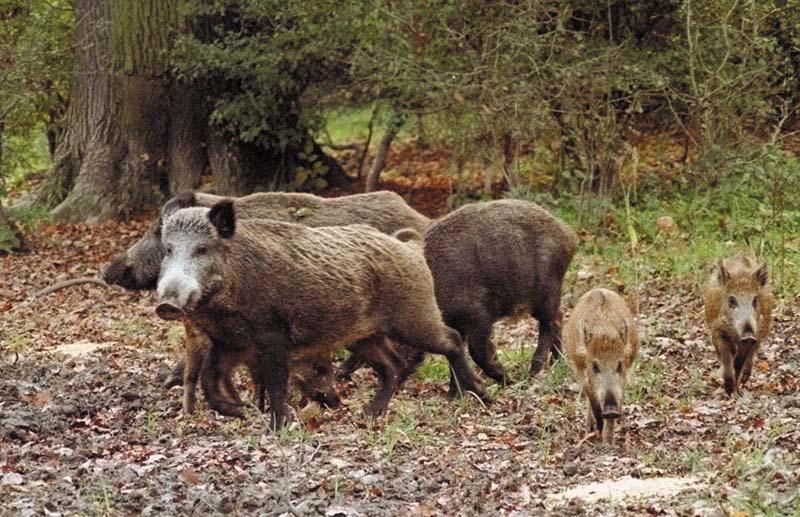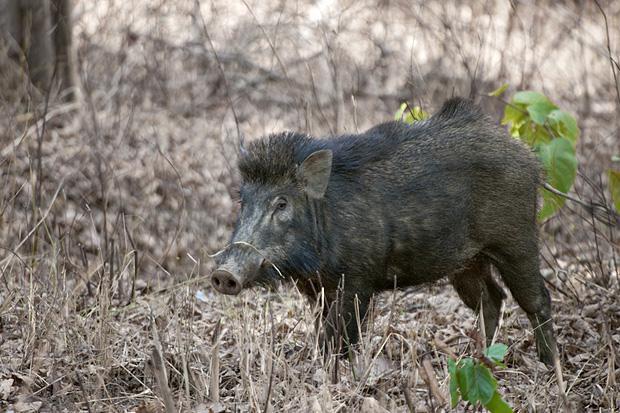The first image is the image on the left, the second image is the image on the right. Considering the images on both sides, is "A wild boar is lying on the ground in the image on the right." valid? Answer yes or no. No. 